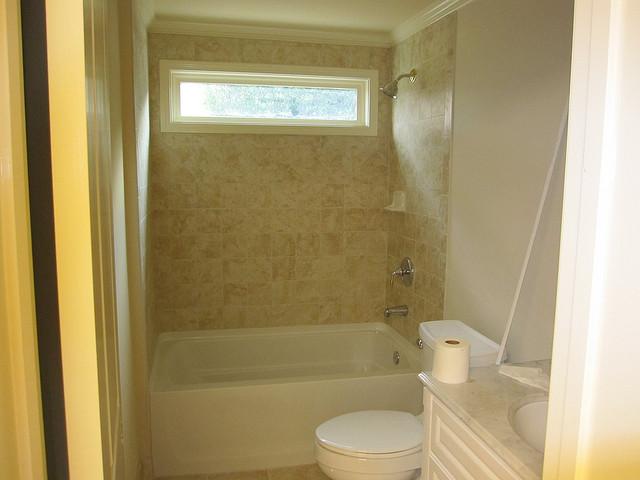What is on the top of the counter?
Concise answer only. Toilet paper. What color are the tiles?
Answer briefly. Tan. What room is this?
Quick response, please. Bathroom. 